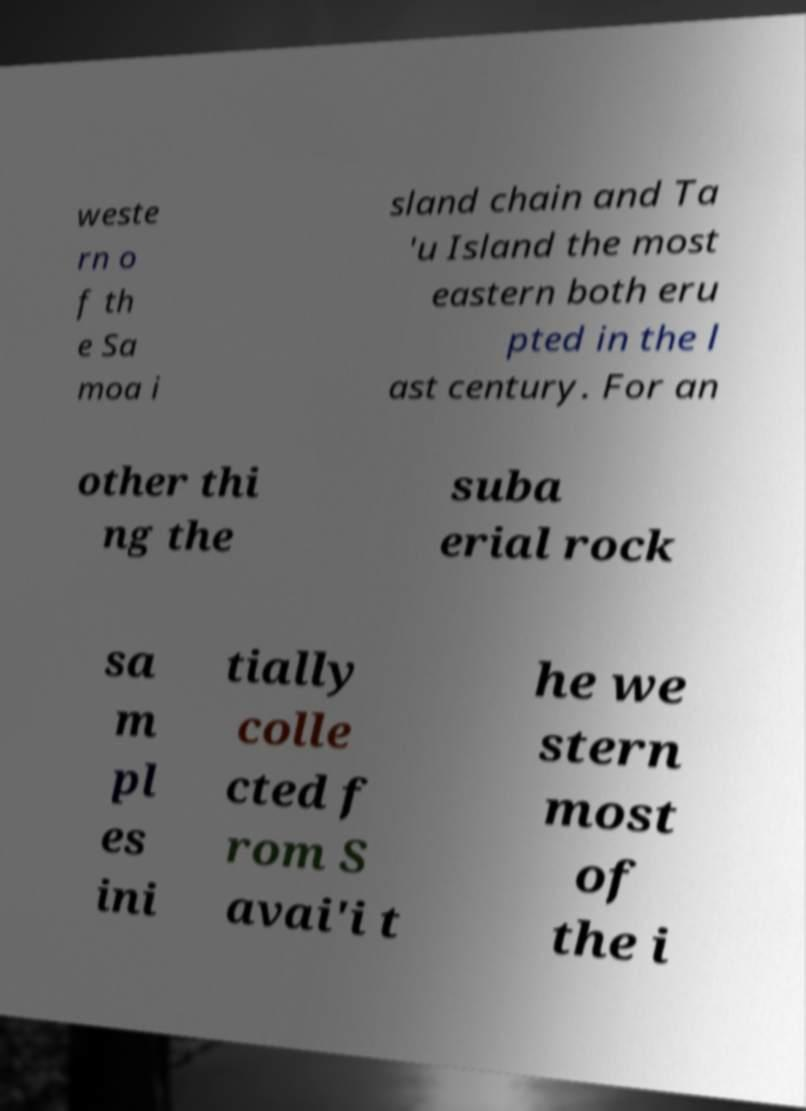For documentation purposes, I need the text within this image transcribed. Could you provide that? weste rn o f th e Sa moa i sland chain and Ta 'u Island the most eastern both eru pted in the l ast century. For an other thi ng the suba erial rock sa m pl es ini tially colle cted f rom S avai'i t he we stern most of the i 